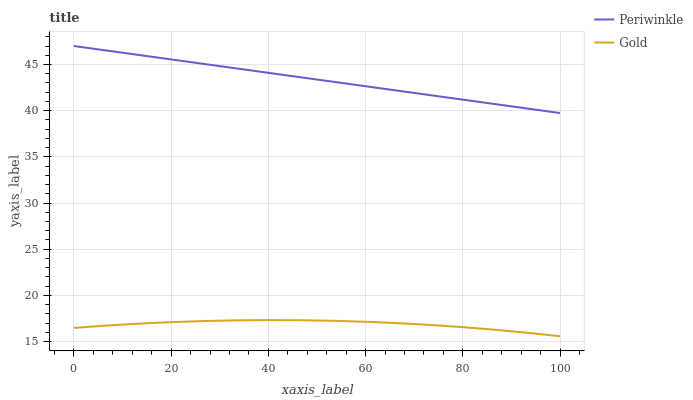Does Gold have the minimum area under the curve?
Answer yes or no. Yes. Does Periwinkle have the maximum area under the curve?
Answer yes or no. Yes. Does Gold have the maximum area under the curve?
Answer yes or no. No. Is Periwinkle the smoothest?
Answer yes or no. Yes. Is Gold the roughest?
Answer yes or no. Yes. Is Gold the smoothest?
Answer yes or no. No. Does Gold have the lowest value?
Answer yes or no. Yes. Does Periwinkle have the highest value?
Answer yes or no. Yes. Does Gold have the highest value?
Answer yes or no. No. Is Gold less than Periwinkle?
Answer yes or no. Yes. Is Periwinkle greater than Gold?
Answer yes or no. Yes. Does Gold intersect Periwinkle?
Answer yes or no. No. 